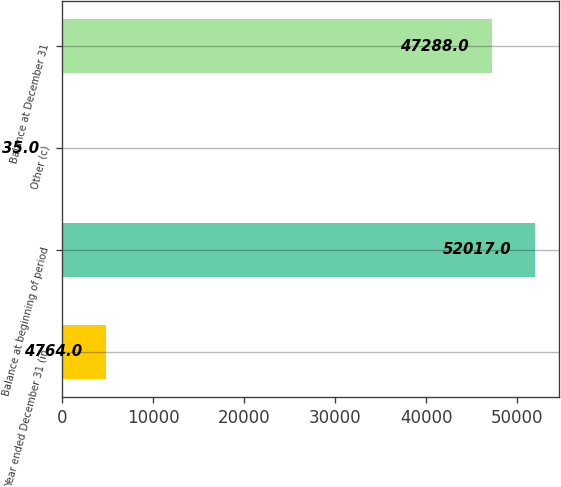Convert chart. <chart><loc_0><loc_0><loc_500><loc_500><bar_chart><fcel>Year ended December 31 (in<fcel>Balance at beginning of period<fcel>Other (c)<fcel>Balance at December 31<nl><fcel>4764<fcel>52017<fcel>35<fcel>47288<nl></chart> 